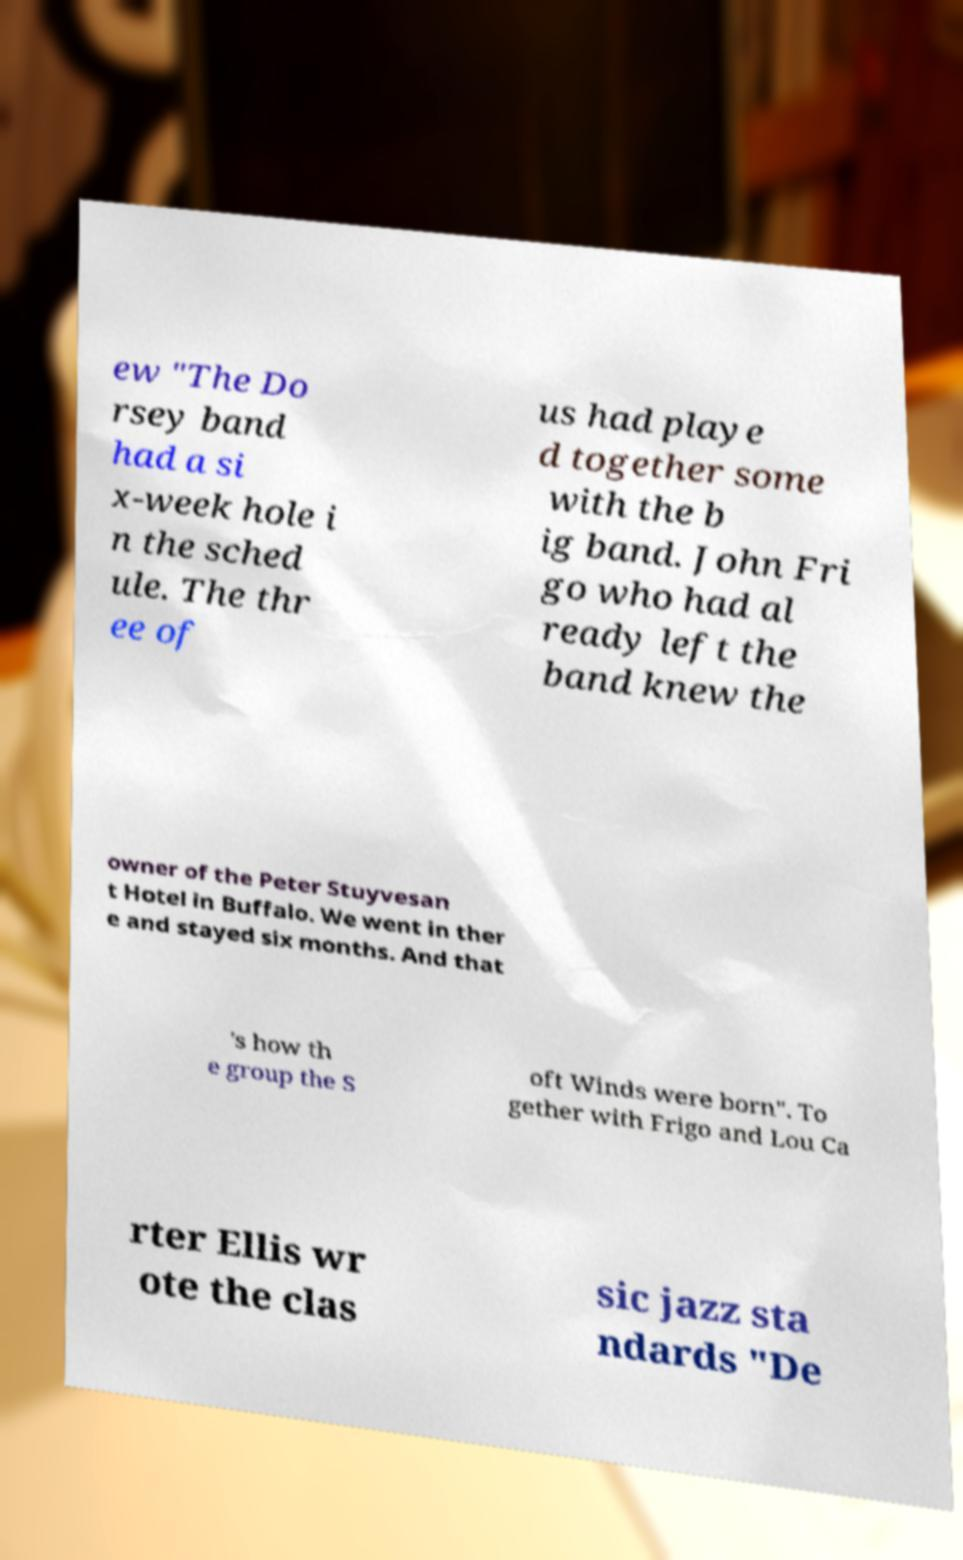Please identify and transcribe the text found in this image. ew "The Do rsey band had a si x-week hole i n the sched ule. The thr ee of us had playe d together some with the b ig band. John Fri go who had al ready left the band knew the owner of the Peter Stuyvesan t Hotel in Buffalo. We went in ther e and stayed six months. And that 's how th e group the S oft Winds were born". To gether with Frigo and Lou Ca rter Ellis wr ote the clas sic jazz sta ndards "De 